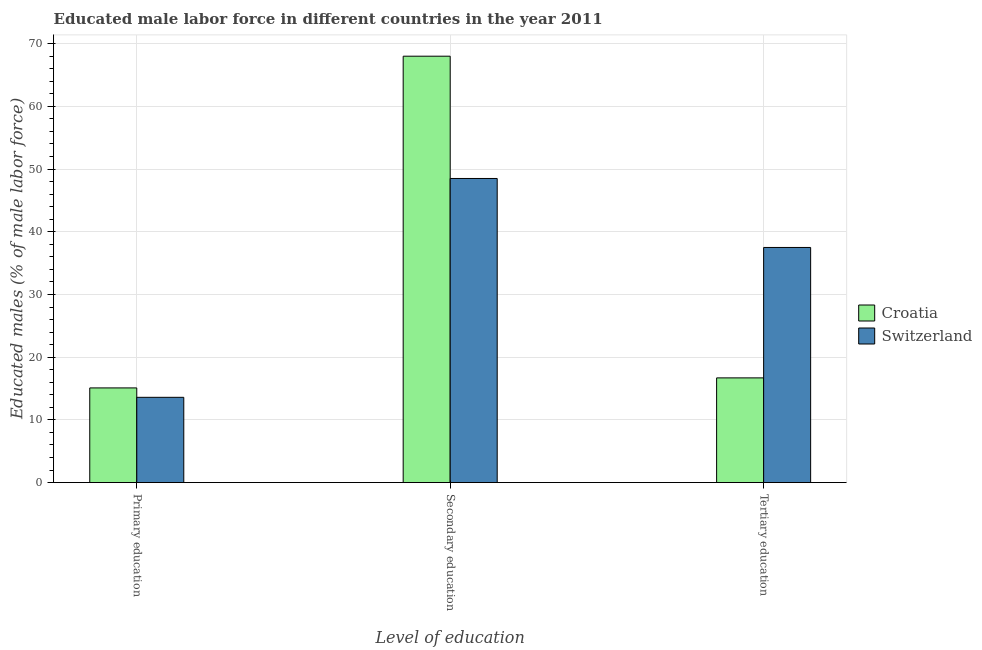How many different coloured bars are there?
Your response must be concise. 2. Are the number of bars on each tick of the X-axis equal?
Give a very brief answer. Yes. What is the label of the 3rd group of bars from the left?
Your answer should be very brief. Tertiary education. What is the percentage of male labor force who received primary education in Switzerland?
Make the answer very short. 13.6. Across all countries, what is the maximum percentage of male labor force who received primary education?
Your answer should be compact. 15.1. Across all countries, what is the minimum percentage of male labor force who received primary education?
Offer a terse response. 13.6. In which country was the percentage of male labor force who received primary education maximum?
Offer a very short reply. Croatia. In which country was the percentage of male labor force who received primary education minimum?
Make the answer very short. Switzerland. What is the total percentage of male labor force who received secondary education in the graph?
Your answer should be very brief. 116.5. What is the difference between the percentage of male labor force who received secondary education in Switzerland and that in Croatia?
Provide a short and direct response. -19.5. What is the difference between the percentage of male labor force who received primary education in Switzerland and the percentage of male labor force who received secondary education in Croatia?
Your answer should be very brief. -54.4. What is the average percentage of male labor force who received primary education per country?
Your response must be concise. 14.35. What is the difference between the percentage of male labor force who received primary education and percentage of male labor force who received tertiary education in Croatia?
Provide a short and direct response. -1.6. In how many countries, is the percentage of male labor force who received tertiary education greater than 8 %?
Ensure brevity in your answer.  2. What is the ratio of the percentage of male labor force who received secondary education in Croatia to that in Switzerland?
Your answer should be very brief. 1.4. Is the difference between the percentage of male labor force who received secondary education in Croatia and Switzerland greater than the difference between the percentage of male labor force who received tertiary education in Croatia and Switzerland?
Your response must be concise. Yes. What is the difference between the highest and the second highest percentage of male labor force who received primary education?
Your response must be concise. 1.5. Is the sum of the percentage of male labor force who received secondary education in Switzerland and Croatia greater than the maximum percentage of male labor force who received tertiary education across all countries?
Your response must be concise. Yes. What does the 2nd bar from the left in Tertiary education represents?
Your answer should be very brief. Switzerland. What does the 1st bar from the right in Primary education represents?
Your answer should be very brief. Switzerland. How many bars are there?
Make the answer very short. 6. Are the values on the major ticks of Y-axis written in scientific E-notation?
Provide a succinct answer. No. Does the graph contain grids?
Ensure brevity in your answer.  Yes. Where does the legend appear in the graph?
Your answer should be very brief. Center right. How are the legend labels stacked?
Provide a short and direct response. Vertical. What is the title of the graph?
Give a very brief answer. Educated male labor force in different countries in the year 2011. What is the label or title of the X-axis?
Provide a short and direct response. Level of education. What is the label or title of the Y-axis?
Ensure brevity in your answer.  Educated males (% of male labor force). What is the Educated males (% of male labor force) of Croatia in Primary education?
Provide a short and direct response. 15.1. What is the Educated males (% of male labor force) in Switzerland in Primary education?
Ensure brevity in your answer.  13.6. What is the Educated males (% of male labor force) of Switzerland in Secondary education?
Keep it short and to the point. 48.5. What is the Educated males (% of male labor force) of Croatia in Tertiary education?
Your response must be concise. 16.7. What is the Educated males (% of male labor force) in Switzerland in Tertiary education?
Keep it short and to the point. 37.5. Across all Level of education, what is the maximum Educated males (% of male labor force) of Croatia?
Offer a terse response. 68. Across all Level of education, what is the maximum Educated males (% of male labor force) in Switzerland?
Give a very brief answer. 48.5. Across all Level of education, what is the minimum Educated males (% of male labor force) in Croatia?
Give a very brief answer. 15.1. Across all Level of education, what is the minimum Educated males (% of male labor force) of Switzerland?
Make the answer very short. 13.6. What is the total Educated males (% of male labor force) of Croatia in the graph?
Give a very brief answer. 99.8. What is the total Educated males (% of male labor force) of Switzerland in the graph?
Your answer should be very brief. 99.6. What is the difference between the Educated males (% of male labor force) in Croatia in Primary education and that in Secondary education?
Your answer should be compact. -52.9. What is the difference between the Educated males (% of male labor force) of Switzerland in Primary education and that in Secondary education?
Keep it short and to the point. -34.9. What is the difference between the Educated males (% of male labor force) of Croatia in Primary education and that in Tertiary education?
Your response must be concise. -1.6. What is the difference between the Educated males (% of male labor force) in Switzerland in Primary education and that in Tertiary education?
Offer a terse response. -23.9. What is the difference between the Educated males (% of male labor force) in Croatia in Secondary education and that in Tertiary education?
Give a very brief answer. 51.3. What is the difference between the Educated males (% of male labor force) of Switzerland in Secondary education and that in Tertiary education?
Make the answer very short. 11. What is the difference between the Educated males (% of male labor force) in Croatia in Primary education and the Educated males (% of male labor force) in Switzerland in Secondary education?
Keep it short and to the point. -33.4. What is the difference between the Educated males (% of male labor force) of Croatia in Primary education and the Educated males (% of male labor force) of Switzerland in Tertiary education?
Your answer should be very brief. -22.4. What is the difference between the Educated males (% of male labor force) of Croatia in Secondary education and the Educated males (% of male labor force) of Switzerland in Tertiary education?
Provide a short and direct response. 30.5. What is the average Educated males (% of male labor force) of Croatia per Level of education?
Offer a terse response. 33.27. What is the average Educated males (% of male labor force) of Switzerland per Level of education?
Provide a short and direct response. 33.2. What is the difference between the Educated males (% of male labor force) in Croatia and Educated males (% of male labor force) in Switzerland in Primary education?
Your answer should be very brief. 1.5. What is the difference between the Educated males (% of male labor force) of Croatia and Educated males (% of male labor force) of Switzerland in Tertiary education?
Give a very brief answer. -20.8. What is the ratio of the Educated males (% of male labor force) of Croatia in Primary education to that in Secondary education?
Your answer should be compact. 0.22. What is the ratio of the Educated males (% of male labor force) of Switzerland in Primary education to that in Secondary education?
Provide a succinct answer. 0.28. What is the ratio of the Educated males (% of male labor force) of Croatia in Primary education to that in Tertiary education?
Offer a terse response. 0.9. What is the ratio of the Educated males (% of male labor force) of Switzerland in Primary education to that in Tertiary education?
Give a very brief answer. 0.36. What is the ratio of the Educated males (% of male labor force) in Croatia in Secondary education to that in Tertiary education?
Your response must be concise. 4.07. What is the ratio of the Educated males (% of male labor force) in Switzerland in Secondary education to that in Tertiary education?
Provide a short and direct response. 1.29. What is the difference between the highest and the second highest Educated males (% of male labor force) of Croatia?
Your answer should be very brief. 51.3. What is the difference between the highest and the second highest Educated males (% of male labor force) of Switzerland?
Provide a short and direct response. 11. What is the difference between the highest and the lowest Educated males (% of male labor force) of Croatia?
Ensure brevity in your answer.  52.9. What is the difference between the highest and the lowest Educated males (% of male labor force) of Switzerland?
Provide a succinct answer. 34.9. 